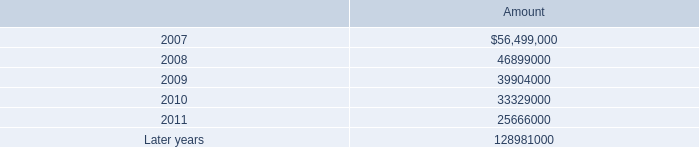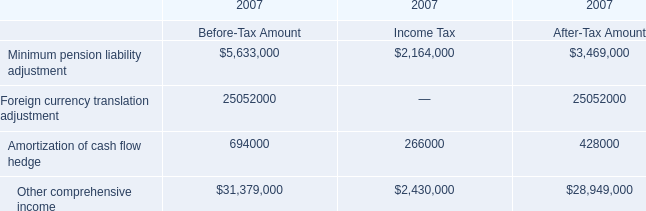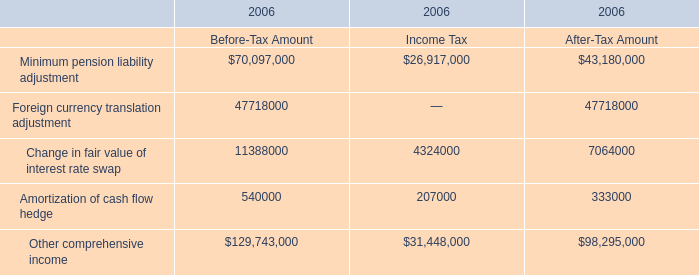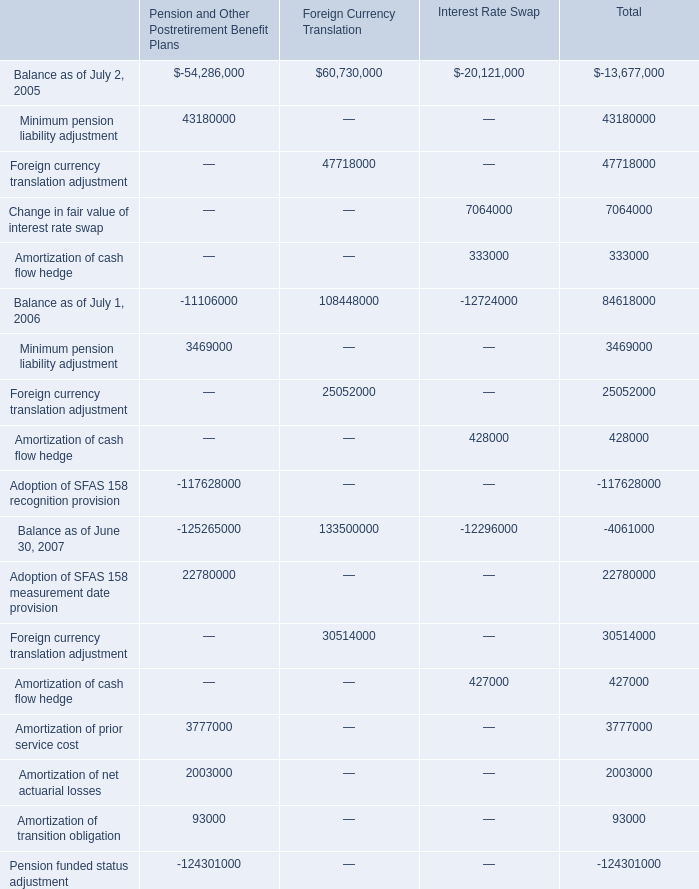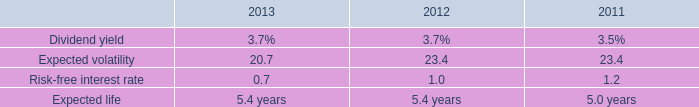what was the percentage change in total rental expense under operating leases from july 1 , 2006 to july 2 , 2007? 
Computations: ((100690000 - 92710000) / 92710000)
Answer: 0.08607. 